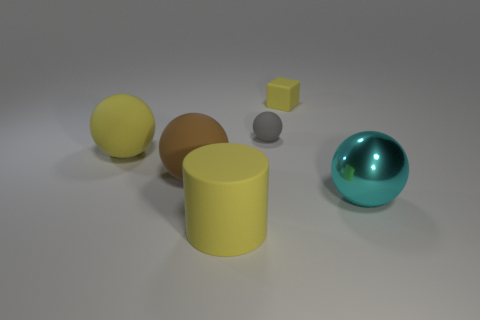What size is the sphere that is on the right side of the tiny gray object?
Keep it short and to the point. Large. There is a yellow thing on the left side of the brown object; is it the same size as the gray sphere?
Offer a very short reply. No. How many big rubber cylinders are there?
Give a very brief answer. 1. Is the number of big objects right of the brown rubber ball greater than the number of tiny green matte cubes?
Your answer should be very brief. Yes. What material is the large thing that is in front of the big cyan object?
Provide a succinct answer. Rubber. What color is the small thing that is the same shape as the large brown object?
Your response must be concise. Gray. How many large rubber objects have the same color as the small rubber block?
Provide a short and direct response. 2. Does the ball that is to the right of the tiny yellow cube have the same size as the yellow object that is on the left side of the yellow cylinder?
Provide a short and direct response. Yes. Does the gray ball have the same size as the thing that is in front of the shiny sphere?
Keep it short and to the point. No. The cyan metallic ball has what size?
Offer a very short reply. Large. 